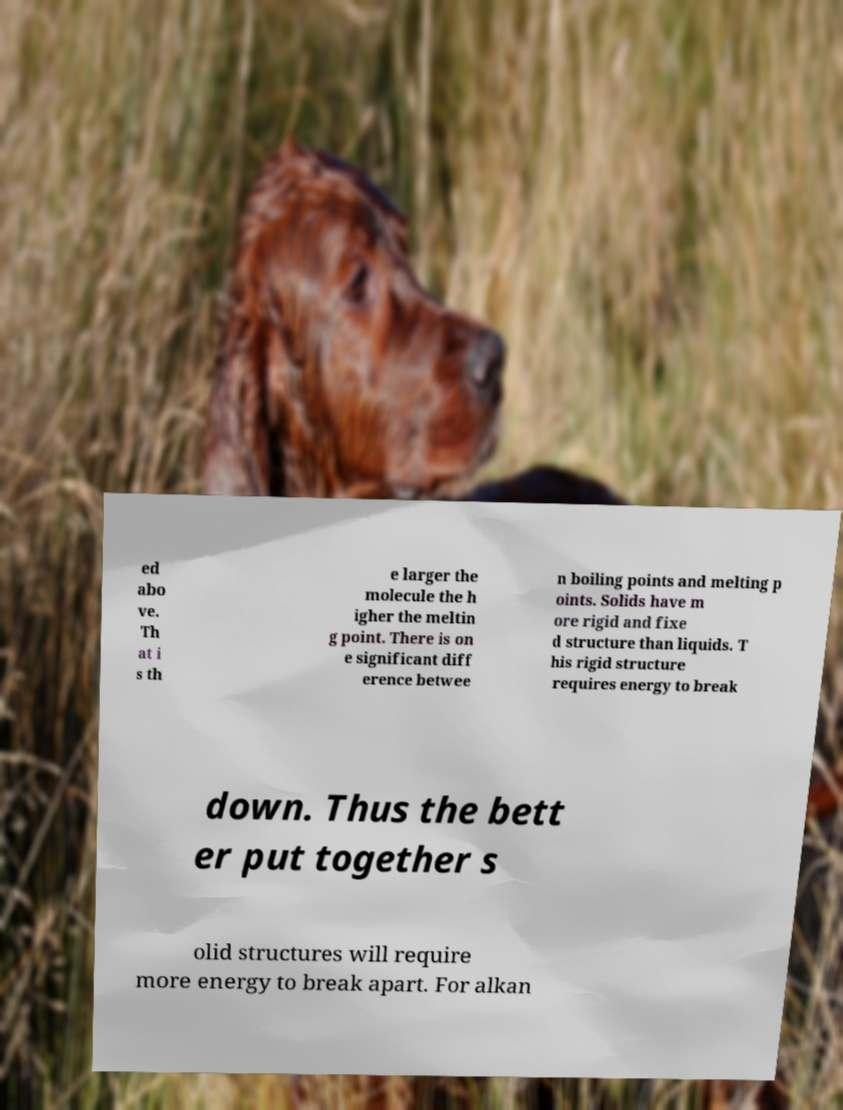Please identify and transcribe the text found in this image. ed abo ve. Th at i s th e larger the molecule the h igher the meltin g point. There is on e significant diff erence betwee n boiling points and melting p oints. Solids have m ore rigid and fixe d structure than liquids. T his rigid structure requires energy to break down. Thus the bett er put together s olid structures will require more energy to break apart. For alkan 